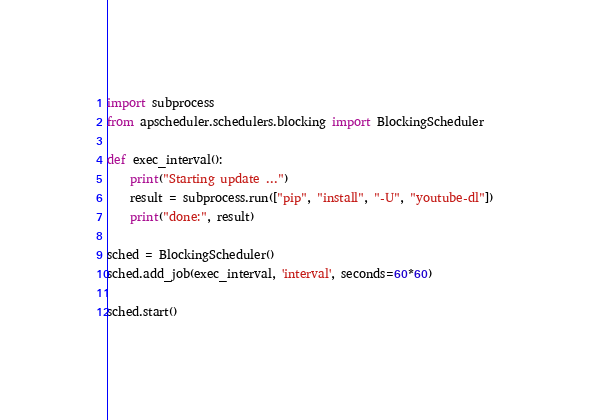Convert code to text. <code><loc_0><loc_0><loc_500><loc_500><_Python_>import subprocess
from apscheduler.schedulers.blocking import BlockingScheduler

def exec_interval():
    print("Starting update ...")
    result = subprocess.run(["pip", "install", "-U", "youtube-dl"])
    print("done:", result)

sched = BlockingScheduler()
sched.add_job(exec_interval, 'interval', seconds=60*60)

sched.start()
</code> 